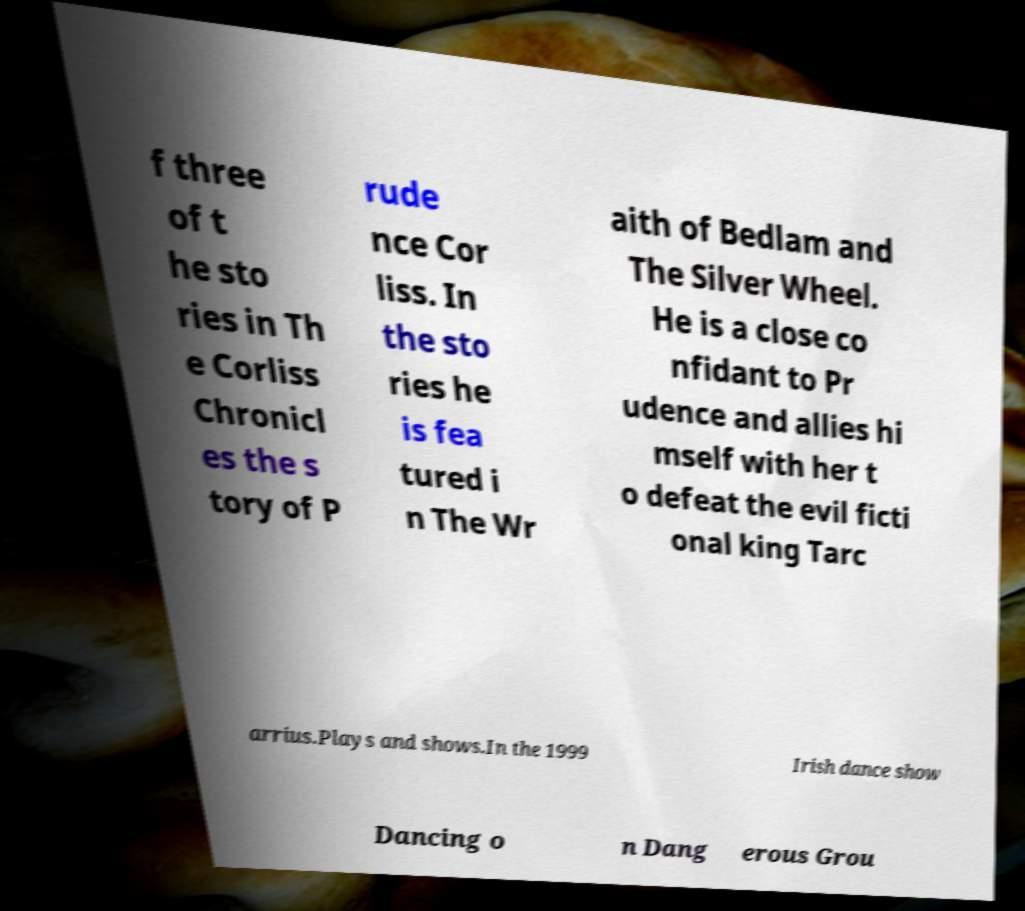Could you extract and type out the text from this image? f three of t he sto ries in Th e Corliss Chronicl es the s tory of P rude nce Cor liss. In the sto ries he is fea tured i n The Wr aith of Bedlam and The Silver Wheel. He is a close co nfidant to Pr udence and allies hi mself with her t o defeat the evil ficti onal king Tarc arrius.Plays and shows.In the 1999 Irish dance show Dancing o n Dang erous Grou 